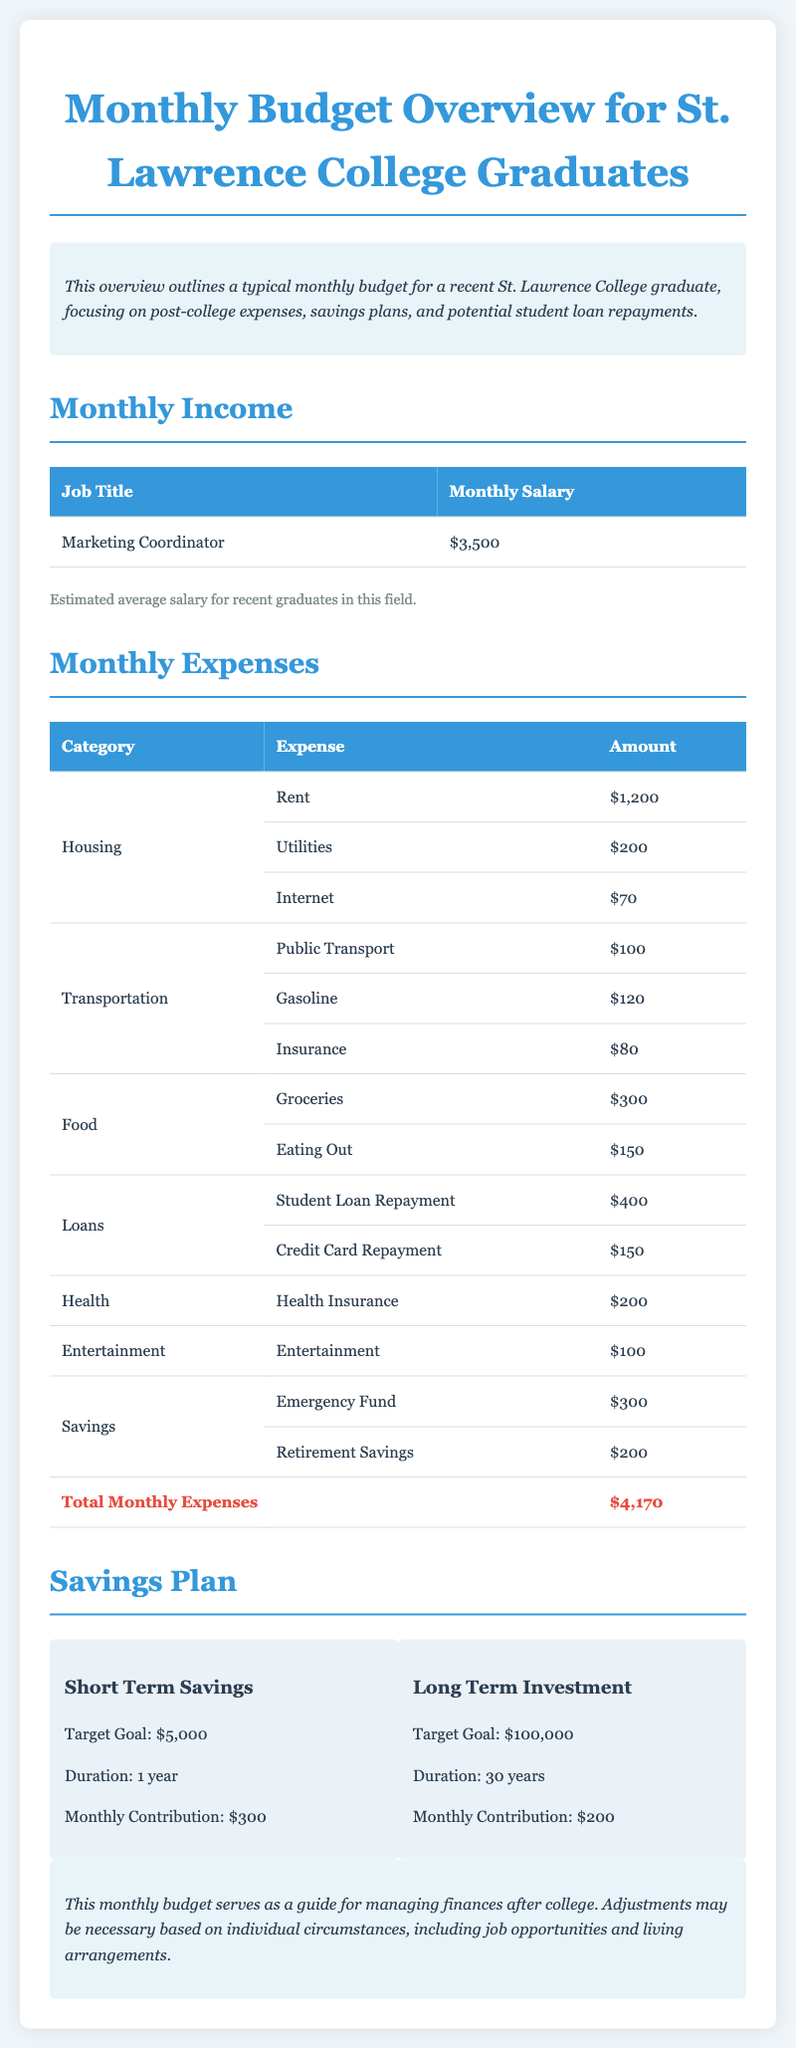What is the monthly salary for a Marketing Coordinator? The monthly salary for a Marketing Coordinator is stated in the document as $3,500.
Answer: $3,500 What is the total monthly expense? The total monthly expense is found in the document by summing up all listed expenses, which equals $4,170.
Answer: $4,170 How much is allocated to Student Loan Repayment? The document specifies that the expense for Student Loan Repayment is $400.
Answer: $400 What is the target goal for short term savings? The target goal for short term savings is mentioned as $5,000 in the savings plan section.
Answer: $5,000 How long is the duration for the long term investment plan? The duration for the long term investment is noted to be 30 years in the document.
Answer: 30 years What is the monthly contribution for the Emergency Fund? The document states that the monthly contribution for the Emergency Fund is $300.
Answer: $300 What category does the $200 health expense fall under? The $200 expense is categorized under Health in the monthly expenses table.
Answer: Health How much is allocated for Credit Card Repayment? The amount allocated for Credit Card Repayment is indicated as $150 in the loans section.
Answer: $150 